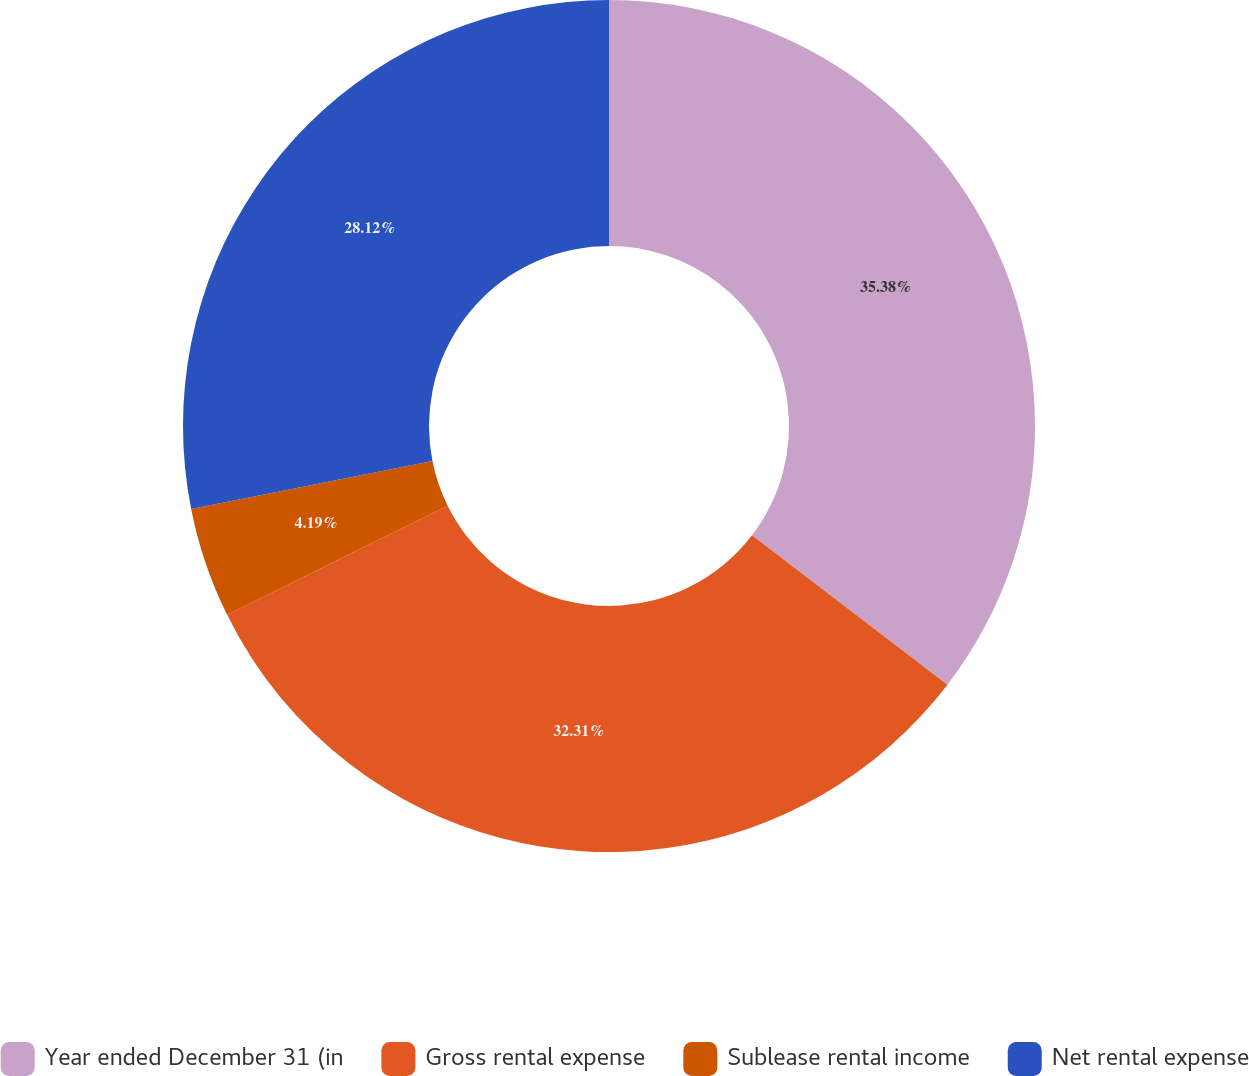Convert chart to OTSL. <chart><loc_0><loc_0><loc_500><loc_500><pie_chart><fcel>Year ended December 31 (in<fcel>Gross rental expense<fcel>Sublease rental income<fcel>Net rental expense<nl><fcel>35.39%<fcel>32.31%<fcel>4.19%<fcel>28.12%<nl></chart> 